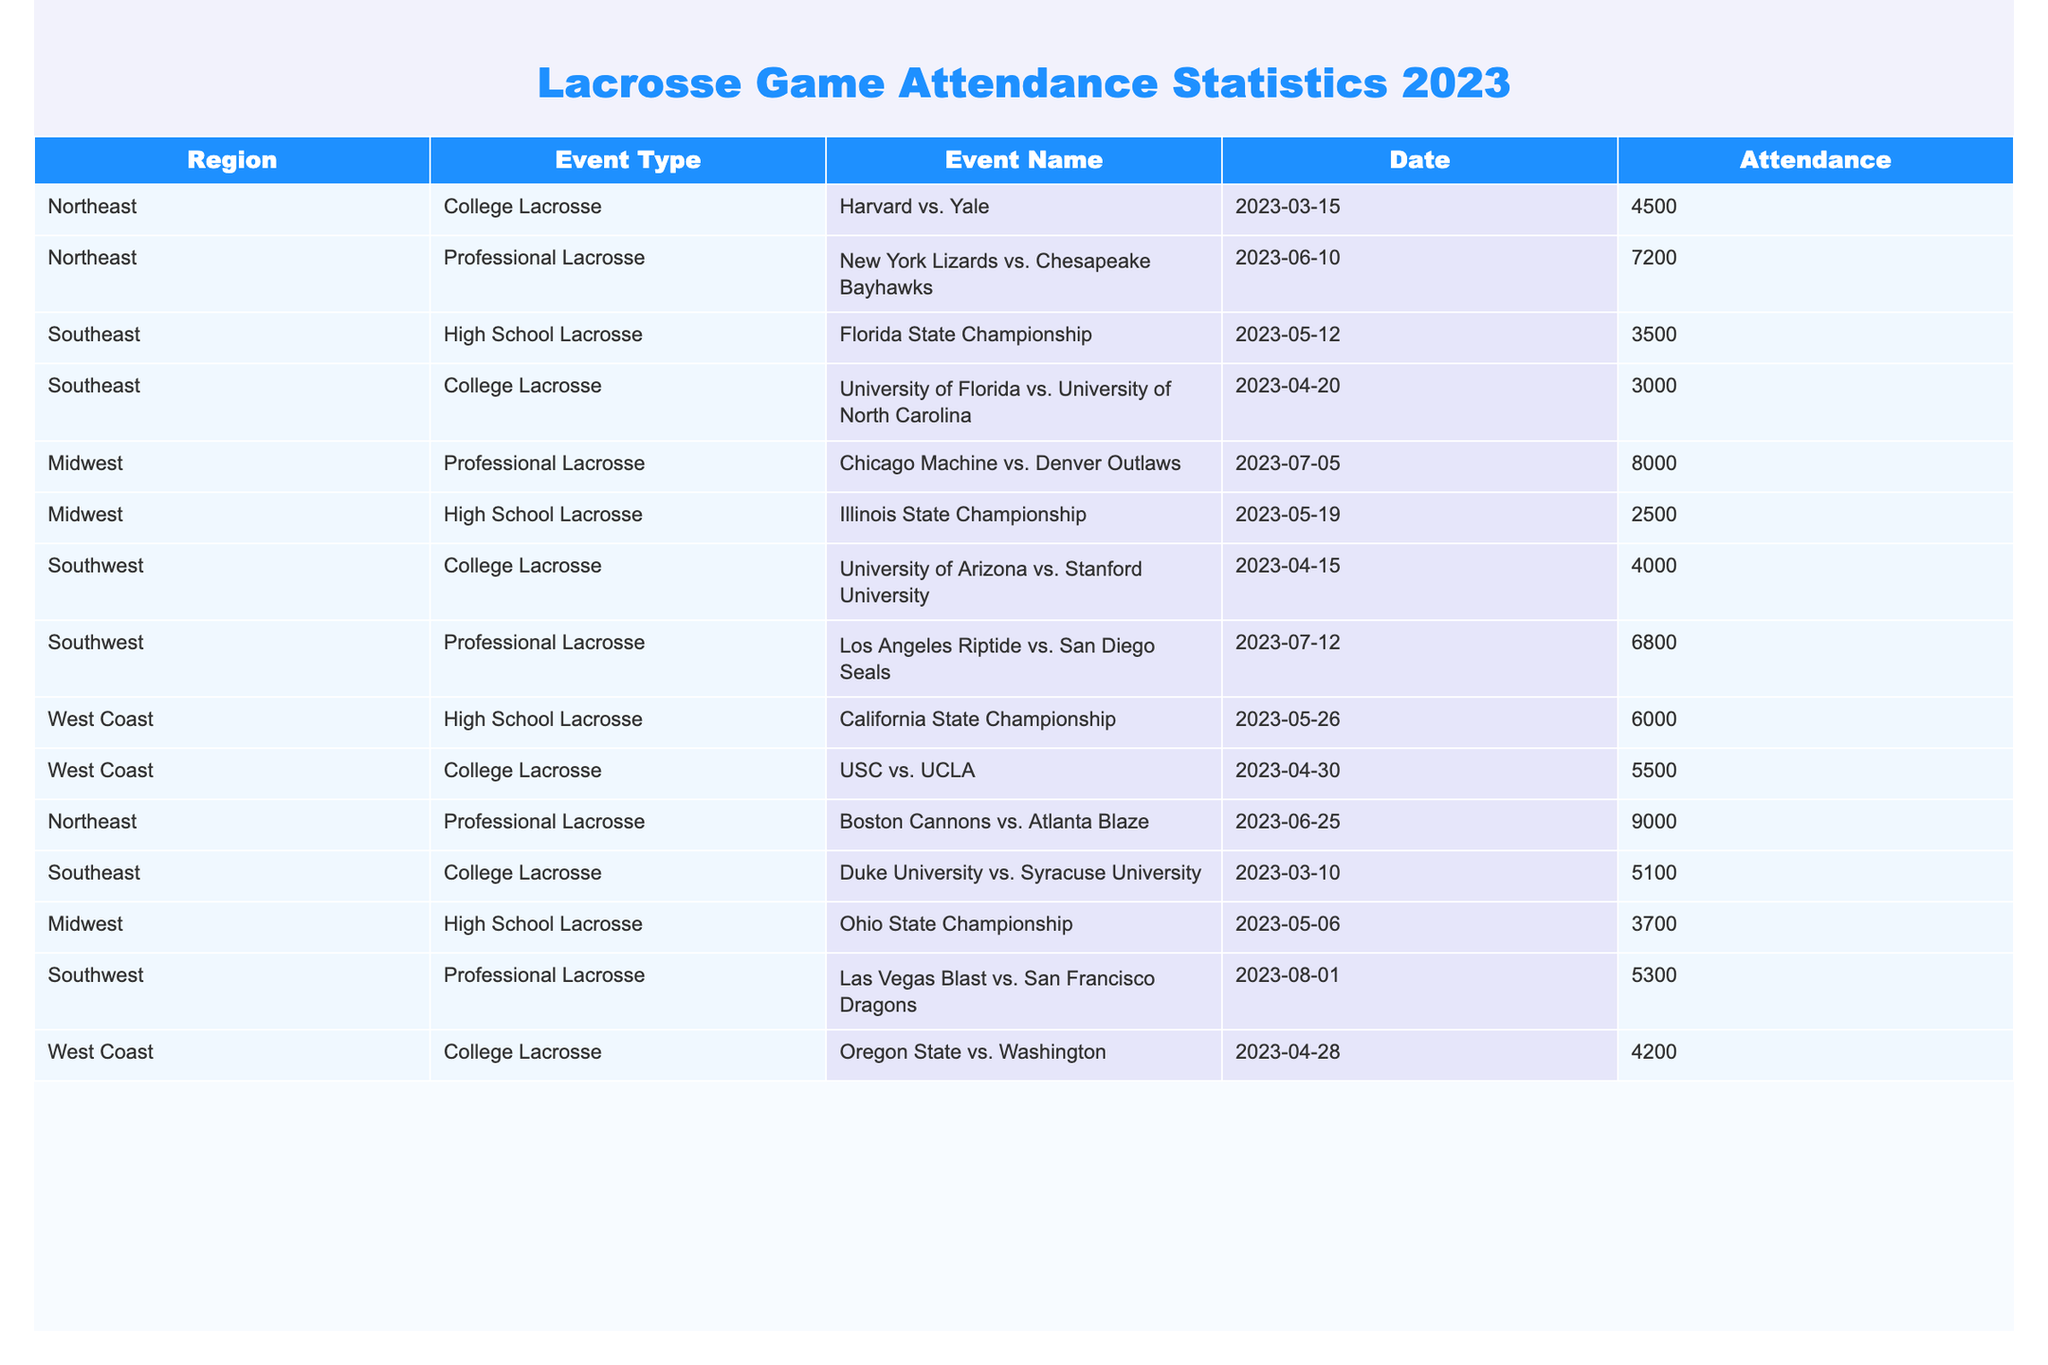What is the total attendance for College Lacrosse events in the Northeast region? From the table, the College Lacrosse events in the Northeast are Harvard vs. Yale with 4500 attendees and Duke University vs. Syracuse University with 5100 attendees. Adding these two numbers gives 4500 + 5100 = 9600.
Answer: 9600 What event had the highest attendance overall? The highest attendance can be found by comparing the attendance figures for all events in the table. The event 'Boston Cannons vs. Atlanta Blaze' has the highest attendance of 9000.
Answer: 9000 How many Professional Lacrosse events were held in the Midwest? The table lists the events in the Midwest, which include one Professional Lacrosse event: 'Chicago Machine vs. Denver Outlaws' with 8000 attendees. There is no other Professional event listed. Counting this results in one event.
Answer: 1 What is the average attendance for High School Lacrosse events across all regions? The High School Lacrosse events listed are: Florida State Championship (3500), Illinois State Championship (2500), and California State Championship (6000). To find the average, sum these attendances: 3500 + 2500 + 6000 = 12000, and divide by the total number of events (3), resulting in an average of 12000/3 = 4000.
Answer: 4000 Is there more attendance at the College Lacrosse events compared to High School Lacrosse events in the Southeast region? In the Southeast, there is one College event (3000) and one High School event (3500). Comparing these numbers, 3000 (College) < 3500 (High School), which means the High School event has more attendance.
Answer: No What is the total attendance for all Professional Lacrosse events? The Professional Lacrosse events listed are: New York Lizards vs. Chesapeake Bayhawks (7200), Boston Cannons vs. Atlanta Blaze (9000), Chicago Machine vs. Denver Outlaws (8000), and Las Vegas Blast vs. San Francisco Dragons (5300). Adding these attendances gives: 7200 + 9000 + 8000 + 5300 = 29500.
Answer: 29500 Which region had the highest total attendance for College Lacrosse events? Analyzing the College Lacrosse events: Northeastern events have 4500 + 5100 = 9600; Southwest events have 4000 + 4200 = 8200; and West Coast event has 5500. Therefore, the Northeast region has the highest total attendance of 9600.
Answer: Northeast How does the attendance of the event 'USC vs. UCLA' compare to the average attendance of College events in that region? The event 'USC vs. UCLA' has an attendance of 5500. The average attendance for College Lacrosse events in the West Coast (5500 from USC vs. UCLA and 4200 from Oregon State vs. Washington) is (5500 + 4200)/2 = 4850. Since 5500 > 4850, this event had higher attendance than the average.
Answer: Higher What percentage of the total attendance for Southwest College Lacrosse events was contributed by the University of Arizona vs. Stanford University? The attendance for the University of Arizona vs. Stanford University is 4000, and the total for the Southwest College Lacrosse events is 4000 (University of Arizona vs. Stanford) + 4200 (Oregon State vs. Washington) = 8200. To find the percentage, calculate (4000/8200) * 100 = 48.78%.
Answer: 48.78% 